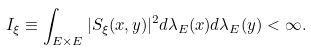<formula> <loc_0><loc_0><loc_500><loc_500>I _ { \xi } \equiv \int _ { E \times E } | S _ { \xi } ( x , y ) | ^ { 2 } d \lambda _ { E } ( x ) d \lambda _ { E } ( y ) < \infty .</formula> 